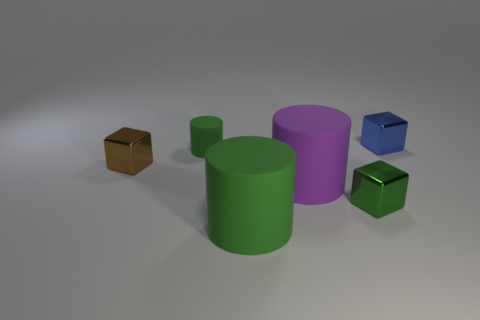How many small things are purple matte objects or yellow matte things?
Your response must be concise. 0. What is the size of the green rubber thing in front of the tiny green shiny block?
Your answer should be very brief. Large. Are there any small metal things of the same color as the small rubber cylinder?
Ensure brevity in your answer.  Yes. The big thing that is the same color as the small rubber thing is what shape?
Provide a short and direct response. Cylinder. How many tiny cylinders are in front of the large purple cylinder behind the green metal object?
Give a very brief answer. 0. How many large purple objects have the same material as the small blue thing?
Offer a very short reply. 0. Are there any matte cylinders left of the brown metal cube?
Offer a very short reply. No. There is a object that is the same size as the purple cylinder; what is its color?
Your answer should be very brief. Green. What number of objects are either cubes behind the small green matte cylinder or red things?
Make the answer very short. 1. There is a metallic cube that is both in front of the tiny green rubber cylinder and on the right side of the small brown block; what size is it?
Your response must be concise. Small. 